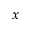Convert formula to latex. <formula><loc_0><loc_0><loc_500><loc_500>x</formula> 